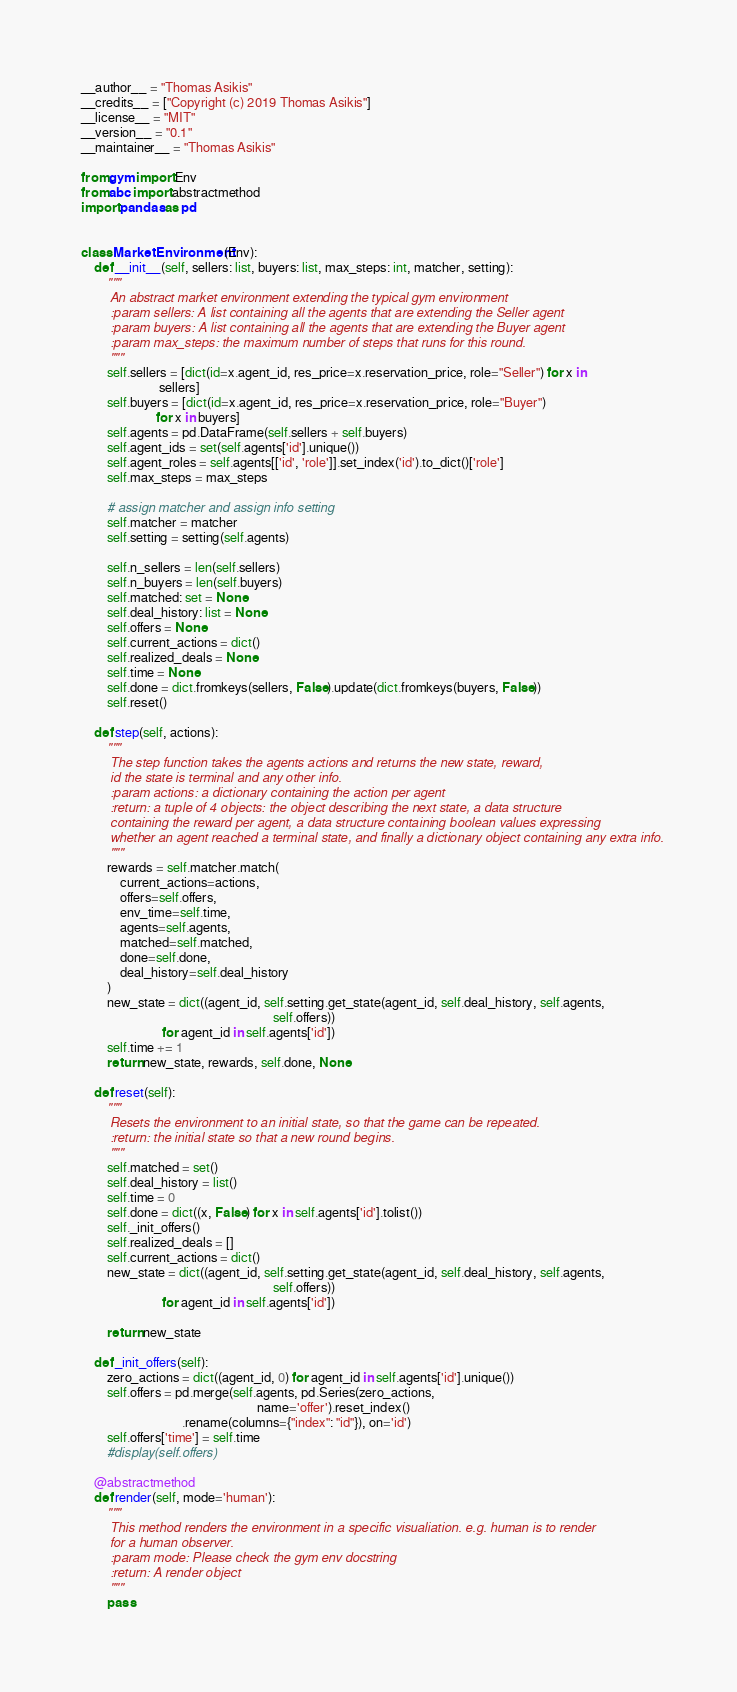Convert code to text. <code><loc_0><loc_0><loc_500><loc_500><_Python_>__author__ = "Thomas Asikis"
__credits__ = ["Copyright (c) 2019 Thomas Asikis"]
__license__ = "MIT"
__version__ = "0.1"
__maintainer__ = "Thomas Asikis"

from gym import Env
from abc import abstractmethod
import pandas as pd


class MarketEnvironment(Env):
    def __init__(self, sellers: list, buyers: list, max_steps: int, matcher, setting):
        """
        An abstract market environment extending the typical gym environment
        :param sellers: A list containing all the agents that are extending the Seller agent
        :param buyers: A list containing all the agents that are extending the Buyer agent
        :param max_steps: the maximum number of steps that runs for this round.
        """
        self.sellers = [dict(id=x.agent_id, res_price=x.reservation_price, role="Seller") for x in
                        sellers]
        self.buyers = [dict(id=x.agent_id, res_price=x.reservation_price, role="Buyer")
                       for x in buyers]
        self.agents = pd.DataFrame(self.sellers + self.buyers)
        self.agent_ids = set(self.agents['id'].unique())
        self.agent_roles = self.agents[['id', 'role']].set_index('id').to_dict()['role']
        self.max_steps = max_steps

        # assign matcher and assign info setting
        self.matcher = matcher
        self.setting = setting(self.agents)

        self.n_sellers = len(self.sellers)
        self.n_buyers = len(self.buyers)
        self.matched: set = None
        self.deal_history: list = None
        self.offers = None
        self.current_actions = dict()
        self.realized_deals = None
        self.time = None
        self.done = dict.fromkeys(sellers, False).update(dict.fromkeys(buyers, False))
        self.reset()

    def step(self, actions):
        """
        The step function takes the agents actions and returns the new state, reward,
        id the state is terminal and any other info.
        :param actions: a dictionary containing the action per agent
        :return: a tuple of 4 objects: the object describing the next state, a data structure
        containing the reward per agent, a data structure containing boolean values expressing
        whether an agent reached a terminal state, and finally a dictionary object containing any extra info.
        """
        rewards = self.matcher.match(
            current_actions=actions,
            offers=self.offers,
            env_time=self.time,
            agents=self.agents,
            matched=self.matched,
            done=self.done,
            deal_history=self.deal_history
        )
        new_state = dict((agent_id, self.setting.get_state(agent_id, self.deal_history, self.agents,
                                                           self.offers))
                         for agent_id in self.agents['id'])
        self.time += 1
        return new_state, rewards, self.done, None

    def reset(self):
        """
        Resets the environment to an initial state, so that the game can be repeated.
        :return: the initial state so that a new round begins.
        """
        self.matched = set()
        self.deal_history = list()
        self.time = 0
        self.done = dict((x, False) for x in self.agents['id'].tolist())
        self._init_offers()
        self.realized_deals = []
        self.current_actions = dict()
        new_state = dict((agent_id, self.setting.get_state(agent_id, self.deal_history, self.agents,
                                                           self.offers))
                         for agent_id in self.agents['id'])

        return new_state

    def _init_offers(self):
        zero_actions = dict((agent_id, 0) for agent_id in self.agents['id'].unique())
        self.offers = pd.merge(self.agents, pd.Series(zero_actions,
                                                      name='offer').reset_index()
                               .rename(columns={"index": "id"}), on='id')
        self.offers['time'] = self.time
        #display(self.offers)

    @abstractmethod
    def render(self, mode='human'):
        """
        This method renders the environment in a specific visualiation. e.g. human is to render
        for a human observer.
        :param mode: Please check the gym env docstring
        :return: A render object
        """
        pass
</code> 